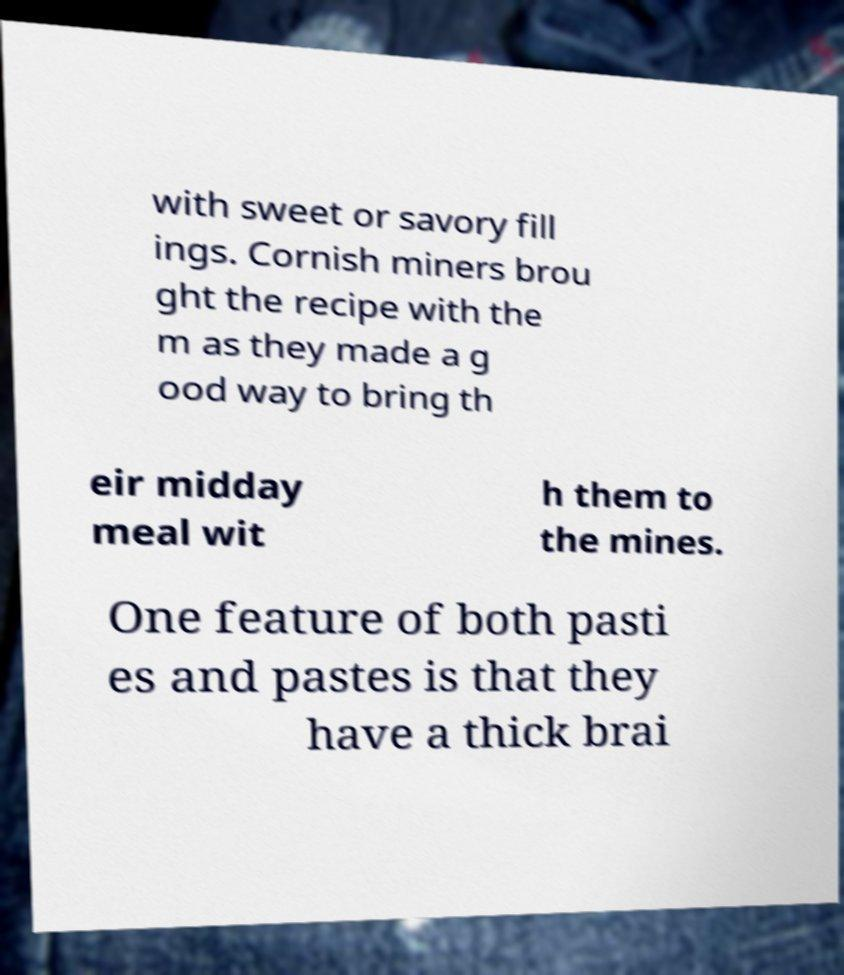Could you extract and type out the text from this image? with sweet or savory fill ings. Cornish miners brou ght the recipe with the m as they made a g ood way to bring th eir midday meal wit h them to the mines. One feature of both pasti es and pastes is that they have a thick brai 